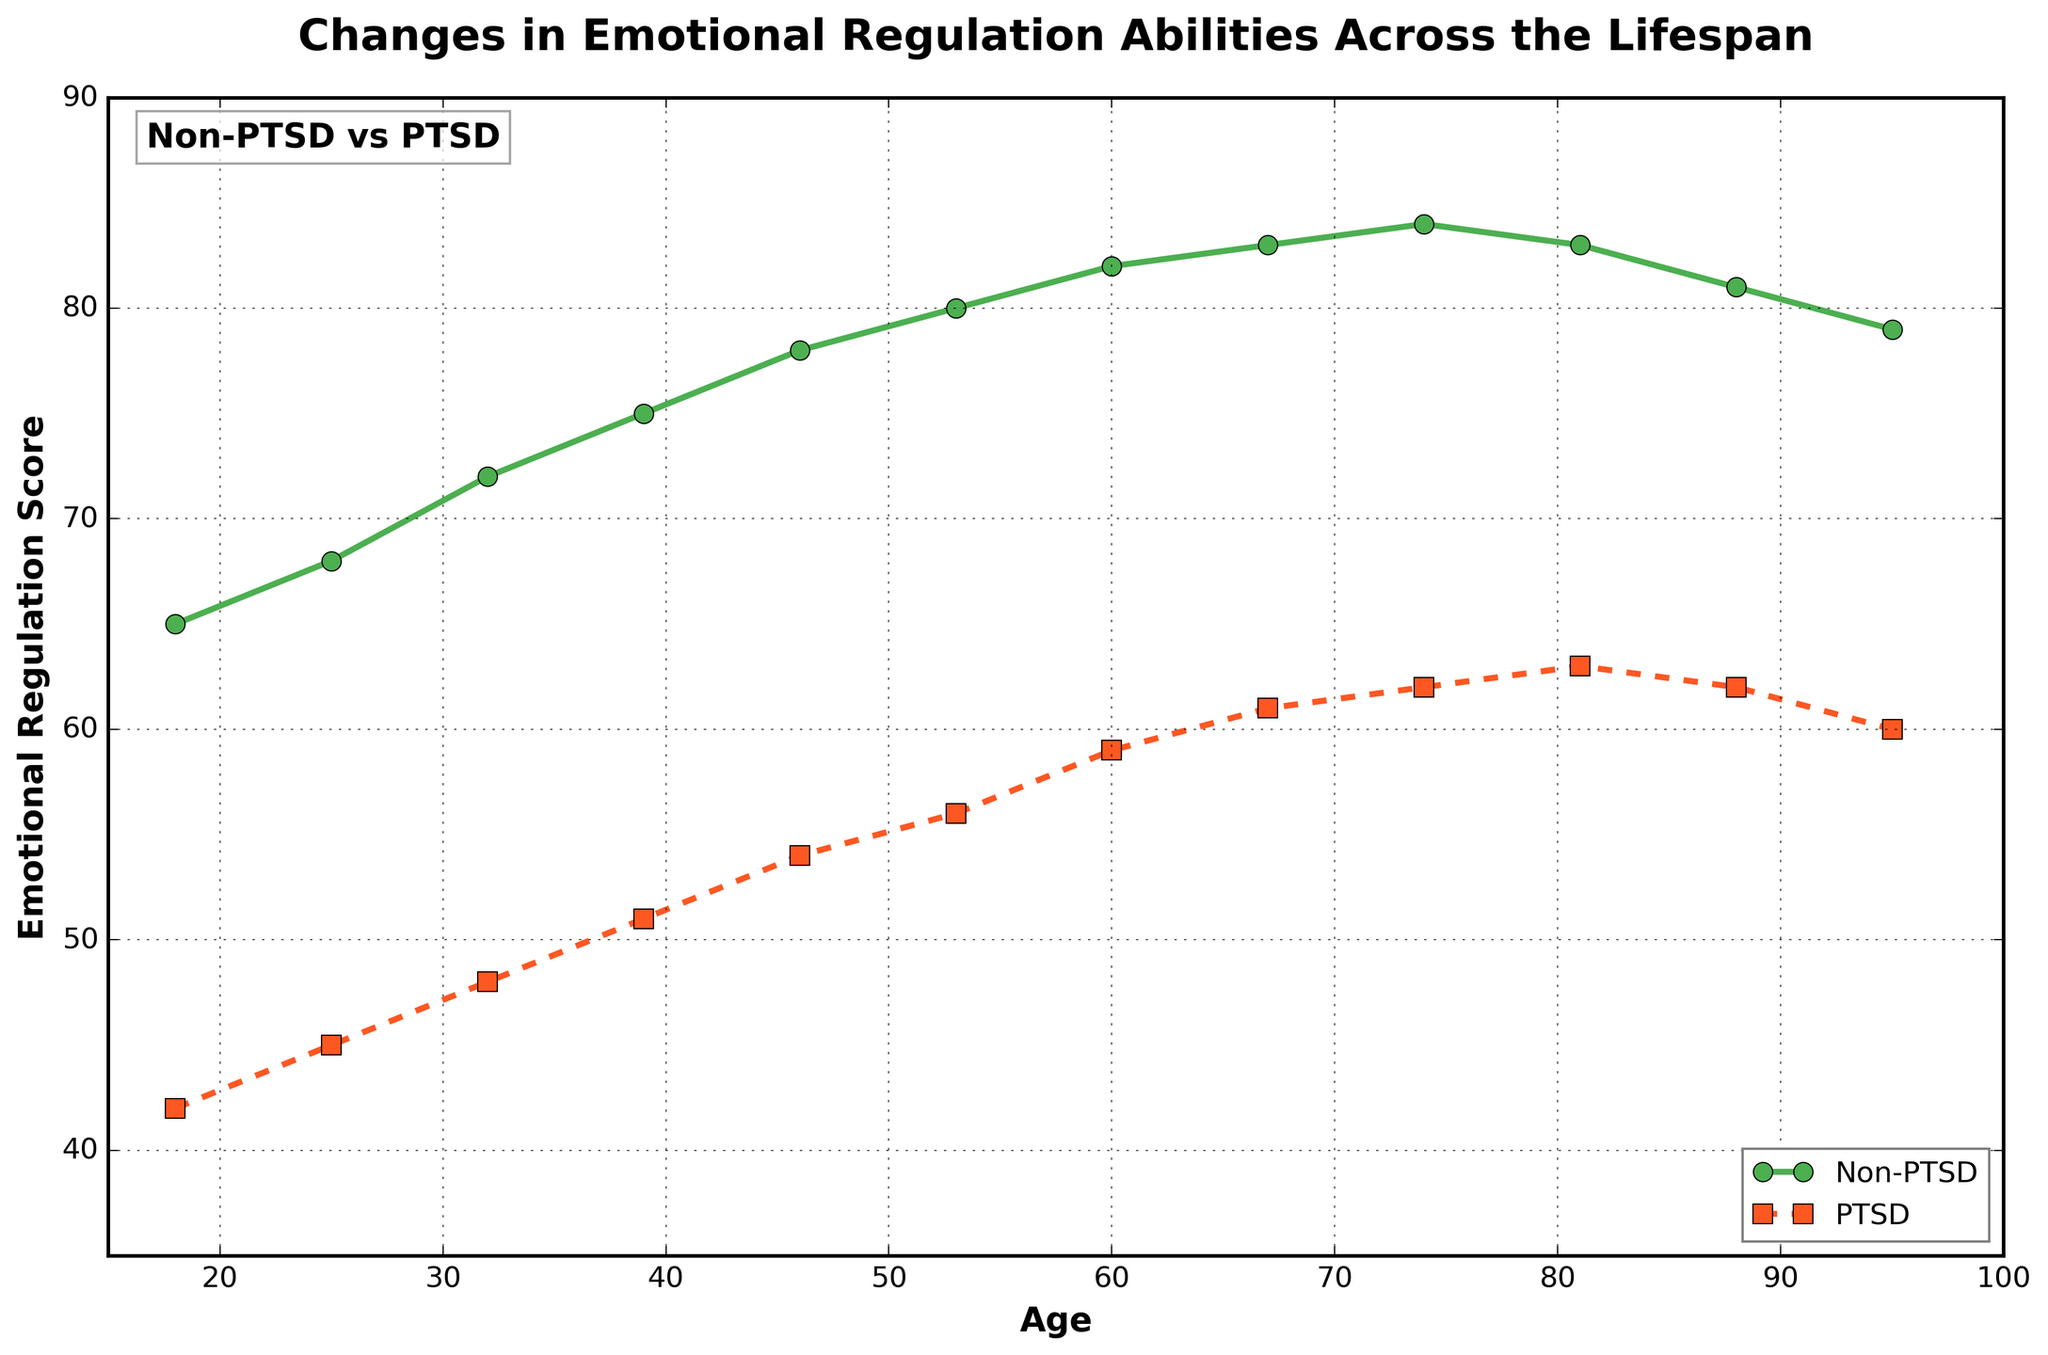What's the most significant improvement in emotional regulation scores with age for the Non-PTSD group? The Non-PTSD group's emotional regulation scores increase from 65 at age 18 to a peak of 84 at age 74, improving by 19 points.
Answer: 19 points At what age does the gap between the PTSD and Non-PTSD groups' emotional regulation scores start to decrease? The gap starts to decrease after age 74, as we see in the chart that the gap begins narrowing when PTSD scores start catching up with Non-PTSD scores.
Answer: Age 74 What is the emotional regulation score difference between the PTSD and Non-PTSD groups at age 60? The Non-PTSD score at age 60 is 82 and the PTSD score is 59. The difference is 82 - 59 = 23.
Answer: 23 Is there an age where the Non-PTSD group's emotional regulation scores stop increasing and start decreasing? The Non-PTSD scores peak at age 74 (score of 84) and start to decline after that, shown by the reduction in scores at ages 81 (83) and 88 (81).
Answer: Age 74 What color represents the PTSD group's emotional regulation scores in the chart? The PTSD group's line is depicted in orange with square markers, as noted in the chart legend.
Answer: Orange Compare the emotional regulation scores of the PTSD group at ages 25 and 81. Which age has the higher score? The score at age 25 is 45 and at age 81 is 63. Since 63 > 45, age 81 has the higher score.
Answer: Age 81 What is the average emotional regulation score for the Non-PTSD group from age 18 to age 95? Sum of scores: 65 + 68 + 72 + 75 + 78 + 80 + 82 + 83 + 84 + 83 + 81 + 79 = 930. Number of age points: 12. Average = 930 / 12 ≈ 77.5.
Answer: ≈ 77.5 By what percentage does the PTSD group's emotional regulation score increase from age 18 to age 74? Initial score at age 18 = 42. Score at age 74 = 62. Increase = 62 - 42 = 20. Percentage increase = (20 / 42) * 100 ≈ 47.62%.
Answer: ≈ 47.62% Which group shows a more significant overall improvement in emotional regulation scores with age? The Non-PTSD group improves from 65 to 84, a 19-point increase, whereas the PTSD group improves from 42 to 63, a 21-point increase. Despite the point increase, the Non-PTSD group shows a higher starting and ending point. Both groups show significant improvement but in different contexts.
Answer: Both in different contexts 